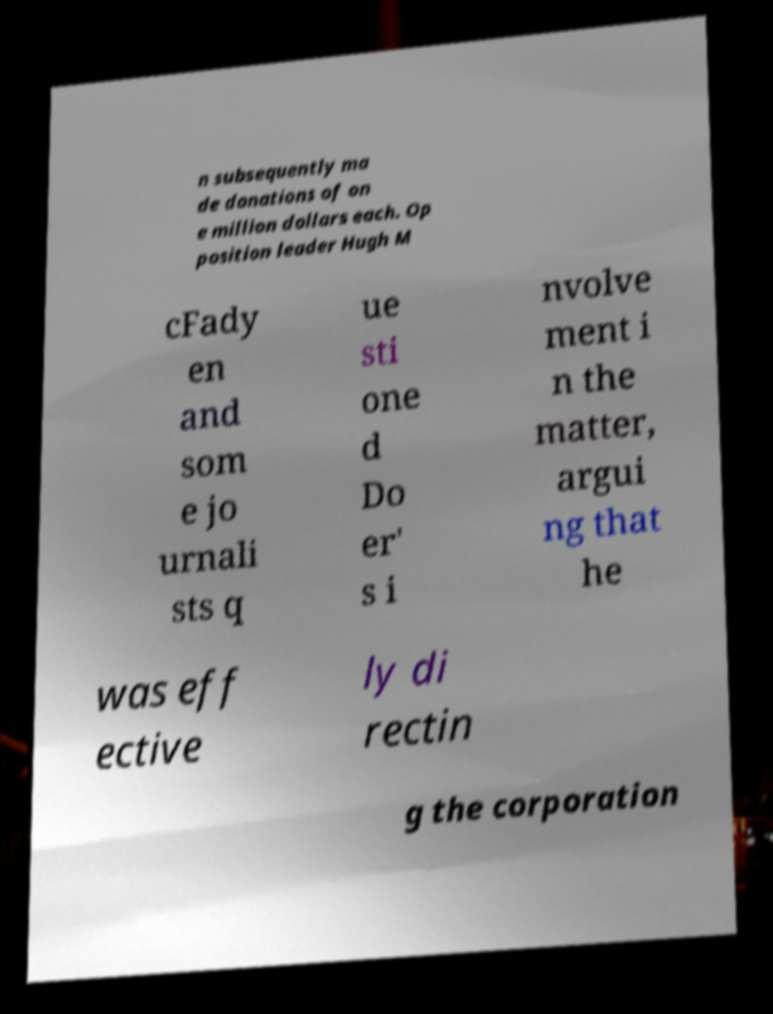Could you assist in decoding the text presented in this image and type it out clearly? n subsequently ma de donations of on e million dollars each. Op position leader Hugh M cFady en and som e jo urnali sts q ue sti one d Do er' s i nvolve ment i n the matter, argui ng that he was eff ective ly di rectin g the corporation 